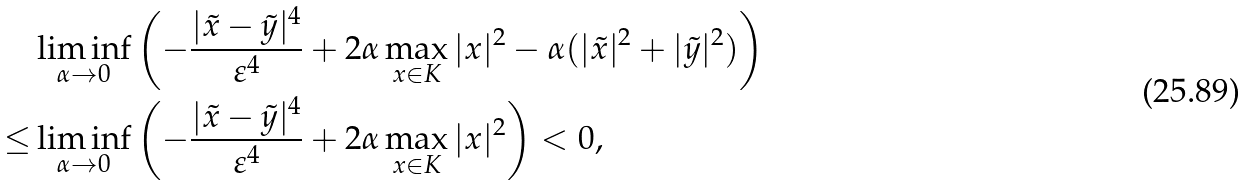<formula> <loc_0><loc_0><loc_500><loc_500>& \liminf _ { \alpha \to 0 } \left ( - \frac { | \tilde { x } - \tilde { y } | ^ { 4 } } { \varepsilon ^ { 4 } } + 2 \alpha \max _ { x \in K } | x | ^ { 2 } - \alpha ( | \tilde { x } | ^ { 2 } + | \tilde { y } | ^ { 2 } ) \right ) \\ \leq & \liminf _ { \alpha \to 0 } \left ( - \frac { | \tilde { x } - \tilde { y } | ^ { 4 } } { \varepsilon ^ { 4 } } + 2 \alpha \max _ { x \in K } | x | ^ { 2 } \right ) < 0 ,</formula> 